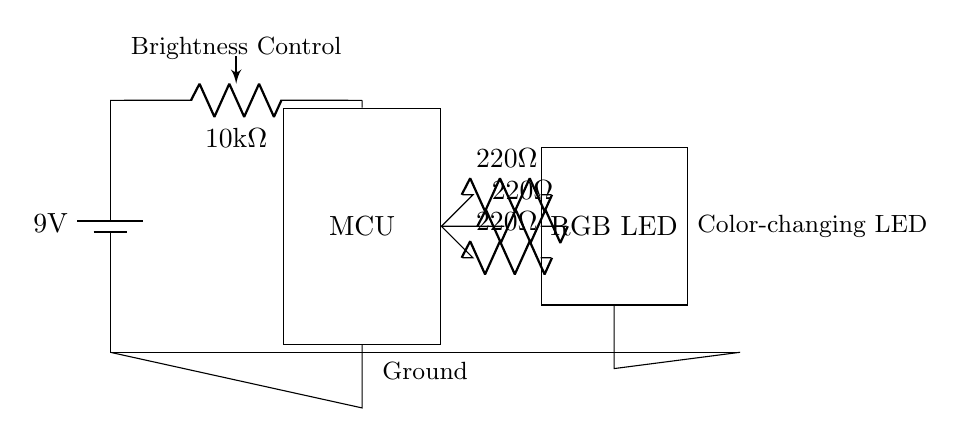What is the voltage of the power supply? The power supply voltage is marked as 9 volts in the diagram. It is the voltage provided by the battery, located at the left side of the circuit.
Answer: 9 volts What type of component is used for brightness control? A potentiometer is used in the circuit to control brightness. It is labeled as a 10k ohm component, and it is connected to the MCU, allowing for variable adjustment of the signal sent to the RGB LED.
Answer: Potentiometer How many resistors are present in the circuit? There are three resistors indicated in the circuit, each labeled as 220 ohms. They are connected in series between the microcontroller and the RGB LED.
Answer: Three What is the function of the RGB LED in this circuit? The RGB LED is designed to change colors based on the signals it receives from the microcontroller. The circuit allows different voltages to be applied to the red, green, and blue pins, controlling the light color.
Answer: Color-changing LED What role does the microcontroller play in this circuit? The microcontroller controls the LED's color by adjusting the output signals based on the potentiometer's position. It processes the input from the potentiometer and outputs appropriate signals to light up the RGB LED in various colors.
Answer: Control color What is the purpose of the resistors connected to the RGB LED? The resistors limit the current flowing through the RGB LED to prevent it from drawing excessive current, which could damage the LED. Each resistor is connected to a different color pin on the RGB LED to manage the current for each color.
Answer: Current limitation 